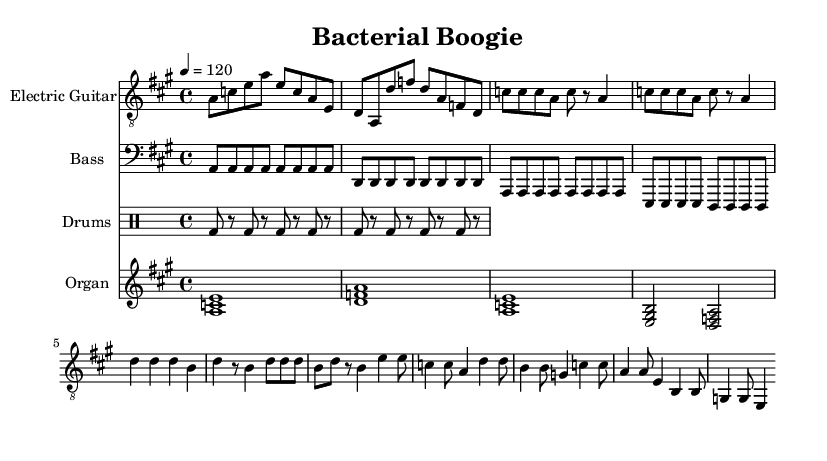What is the key signature of this music? The key signature is A major, which has three sharps (F#, C#, and G#). This can be identified in the beginning section of the sheet music where the key signature is indicated.
Answer: A major What is the time signature of the music? The time signature is 4/4, which indicates that there are four beats in each measure and the quarter note gets one beat. This is visible at the beginning of the score.
Answer: 4/4 What is the tempo marking in the sheet music? The tempo marking is 120 beats per minute. This tempo is stated in the sequence "4 = 120" right after the time signature and key signature, indicating the speed of the music.
Answer: 120 How many measures are in the Electric Guitar part? The Electric Guitar part consists of 16 measures, which can be counted by looking at the grouping of the notes and the vertical lines that separate each measure throughout the staff.
Answer: 16 What is the primary instrument in this piece? The primary instrument in this piece is the Electric Guitar, which has its own staff labeled as "Electric Guitar" at the beginning of the score, indicating it is one of the main instruments featured.
Answer: Electric Guitar What chord follows the A major chord in the organ part? The chord that follows the A major chord is the D major chord, which is the second chord indicated in the organ chords section of the music.
Answer: D major How is the rhythm pattern of the drums primarily structured? The rhythm pattern of the drums is primarily structured as a steady eighth-note kick drum pattern, where the bass drum plays consistently every eighth note, indicated by "bd" in the drum staff.
Answer: Eighth notes 